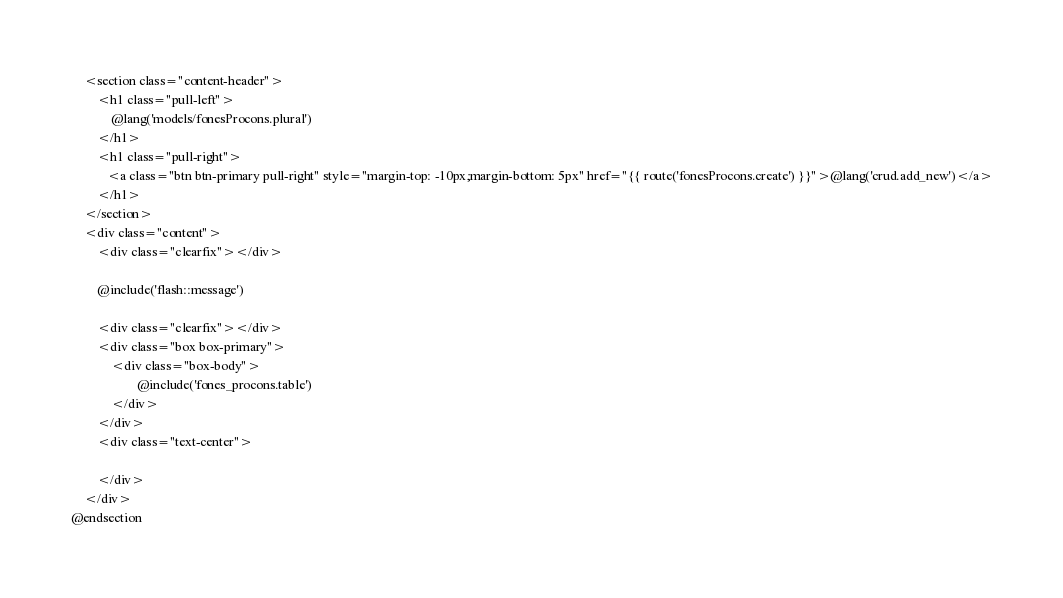Convert code to text. <code><loc_0><loc_0><loc_500><loc_500><_PHP_>    <section class="content-header">
        <h1 class="pull-left">
            @lang('models/fonesProcons.plural')
        </h1>
        <h1 class="pull-right">
           <a class="btn btn-primary pull-right" style="margin-top: -10px;margin-bottom: 5px" href="{{ route('fonesProcons.create') }}">@lang('crud.add_new')</a>
        </h1>
    </section>
    <div class="content">
        <div class="clearfix"></div>

        @include('flash::message')

        <div class="clearfix"></div>
        <div class="box box-primary">
            <div class="box-body">
                    @include('fones_procons.table')
            </div>
        </div>
        <div class="text-center">
        
        </div>
    </div>
@endsection

</code> 